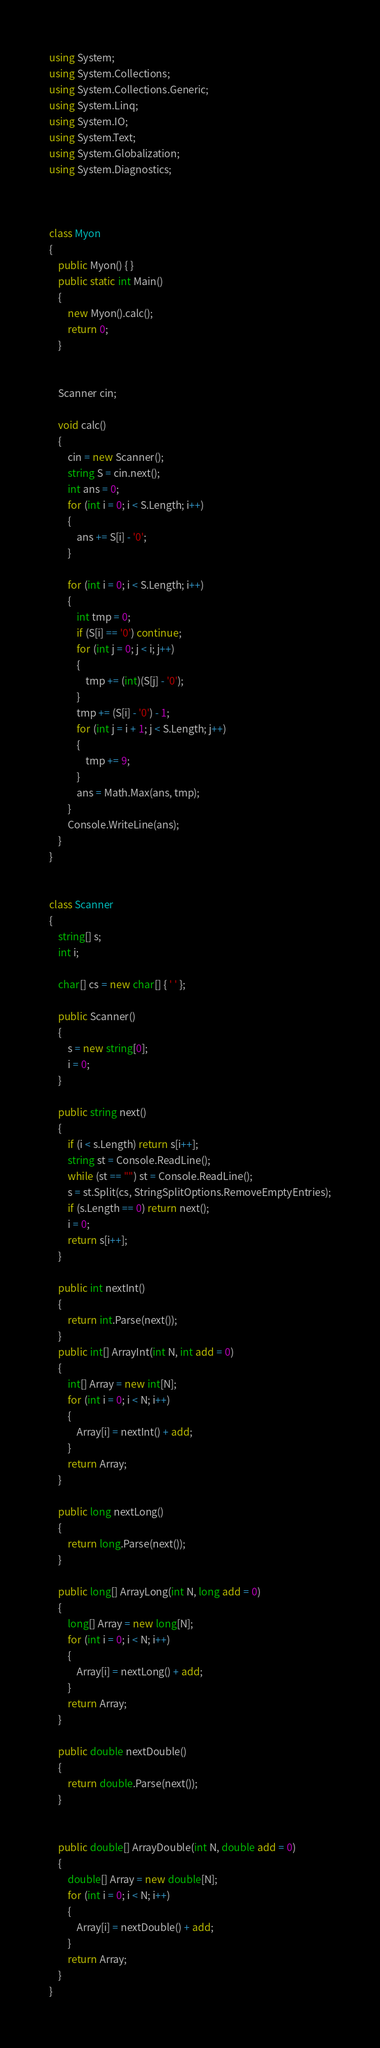<code> <loc_0><loc_0><loc_500><loc_500><_C#_>using System;
using System.Collections;
using System.Collections.Generic;
using System.Linq;
using System.IO;
using System.Text;
using System.Globalization;
using System.Diagnostics;



class Myon
{
    public Myon() { }
    public static int Main()
    {
        new Myon().calc();
        return 0;
    }


    Scanner cin;

    void calc()
    {
        cin = new Scanner();
        string S = cin.next();
        int ans = 0;
        for (int i = 0; i < S.Length; i++)
        {
            ans += S[i] - '0';
        }

        for (int i = 0; i < S.Length; i++)
        {
            int tmp = 0;
            if (S[i] == '0') continue;
            for (int j = 0; j < i; j++)
            {
                tmp += (int)(S[j] - '0');
            }
            tmp += (S[i] - '0') - 1;
            for (int j = i + 1; j < S.Length; j++)
            {
                tmp += 9;
            }
            ans = Math.Max(ans, tmp);
        }
        Console.WriteLine(ans);
    }
}


class Scanner
{
    string[] s;
    int i;

    char[] cs = new char[] { ' ' };

    public Scanner()
    {
        s = new string[0];
        i = 0;
    }

    public string next()
    {
        if (i < s.Length) return s[i++];
        string st = Console.ReadLine();
        while (st == "") st = Console.ReadLine();
        s = st.Split(cs, StringSplitOptions.RemoveEmptyEntries);
        if (s.Length == 0) return next();
        i = 0;
        return s[i++];
    }

    public int nextInt()
    {
        return int.Parse(next());
    }
    public int[] ArrayInt(int N, int add = 0)
    {
        int[] Array = new int[N];
        for (int i = 0; i < N; i++)
        {
            Array[i] = nextInt() + add;
        }
        return Array;
    }

    public long nextLong()
    {
        return long.Parse(next());
    }

    public long[] ArrayLong(int N, long add = 0)
    {
        long[] Array = new long[N];
        for (int i = 0; i < N; i++)
        {
            Array[i] = nextLong() + add;
        }
        return Array;
    }

    public double nextDouble()
    {
        return double.Parse(next());
    }


    public double[] ArrayDouble(int N, double add = 0)
    {
        double[] Array = new double[N];
        for (int i = 0; i < N; i++)
        {
            Array[i] = nextDouble() + add;
        }
        return Array;
    }
}</code> 